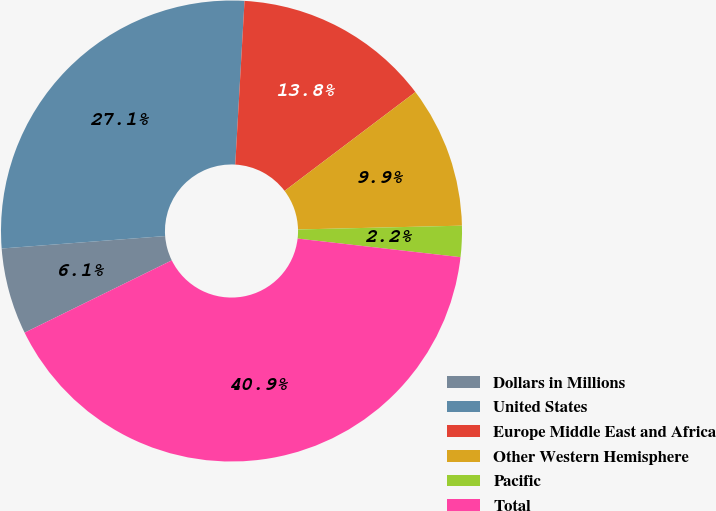Convert chart to OTSL. <chart><loc_0><loc_0><loc_500><loc_500><pie_chart><fcel>Dollars in Millions<fcel>United States<fcel>Europe Middle East and Africa<fcel>Other Western Hemisphere<fcel>Pacific<fcel>Total<nl><fcel>6.06%<fcel>27.11%<fcel>13.8%<fcel>9.93%<fcel>2.18%<fcel>40.92%<nl></chart> 